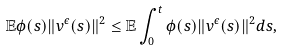Convert formula to latex. <formula><loc_0><loc_0><loc_500><loc_500>\mathbb { E } \phi ( s ) \| v ^ { \epsilon } ( s ) \| ^ { 2 } \leq \mathbb { E } \int _ { 0 } ^ { t } \phi ( s ) \| v ^ { \epsilon } ( s ) \| ^ { 2 } d s ,</formula> 